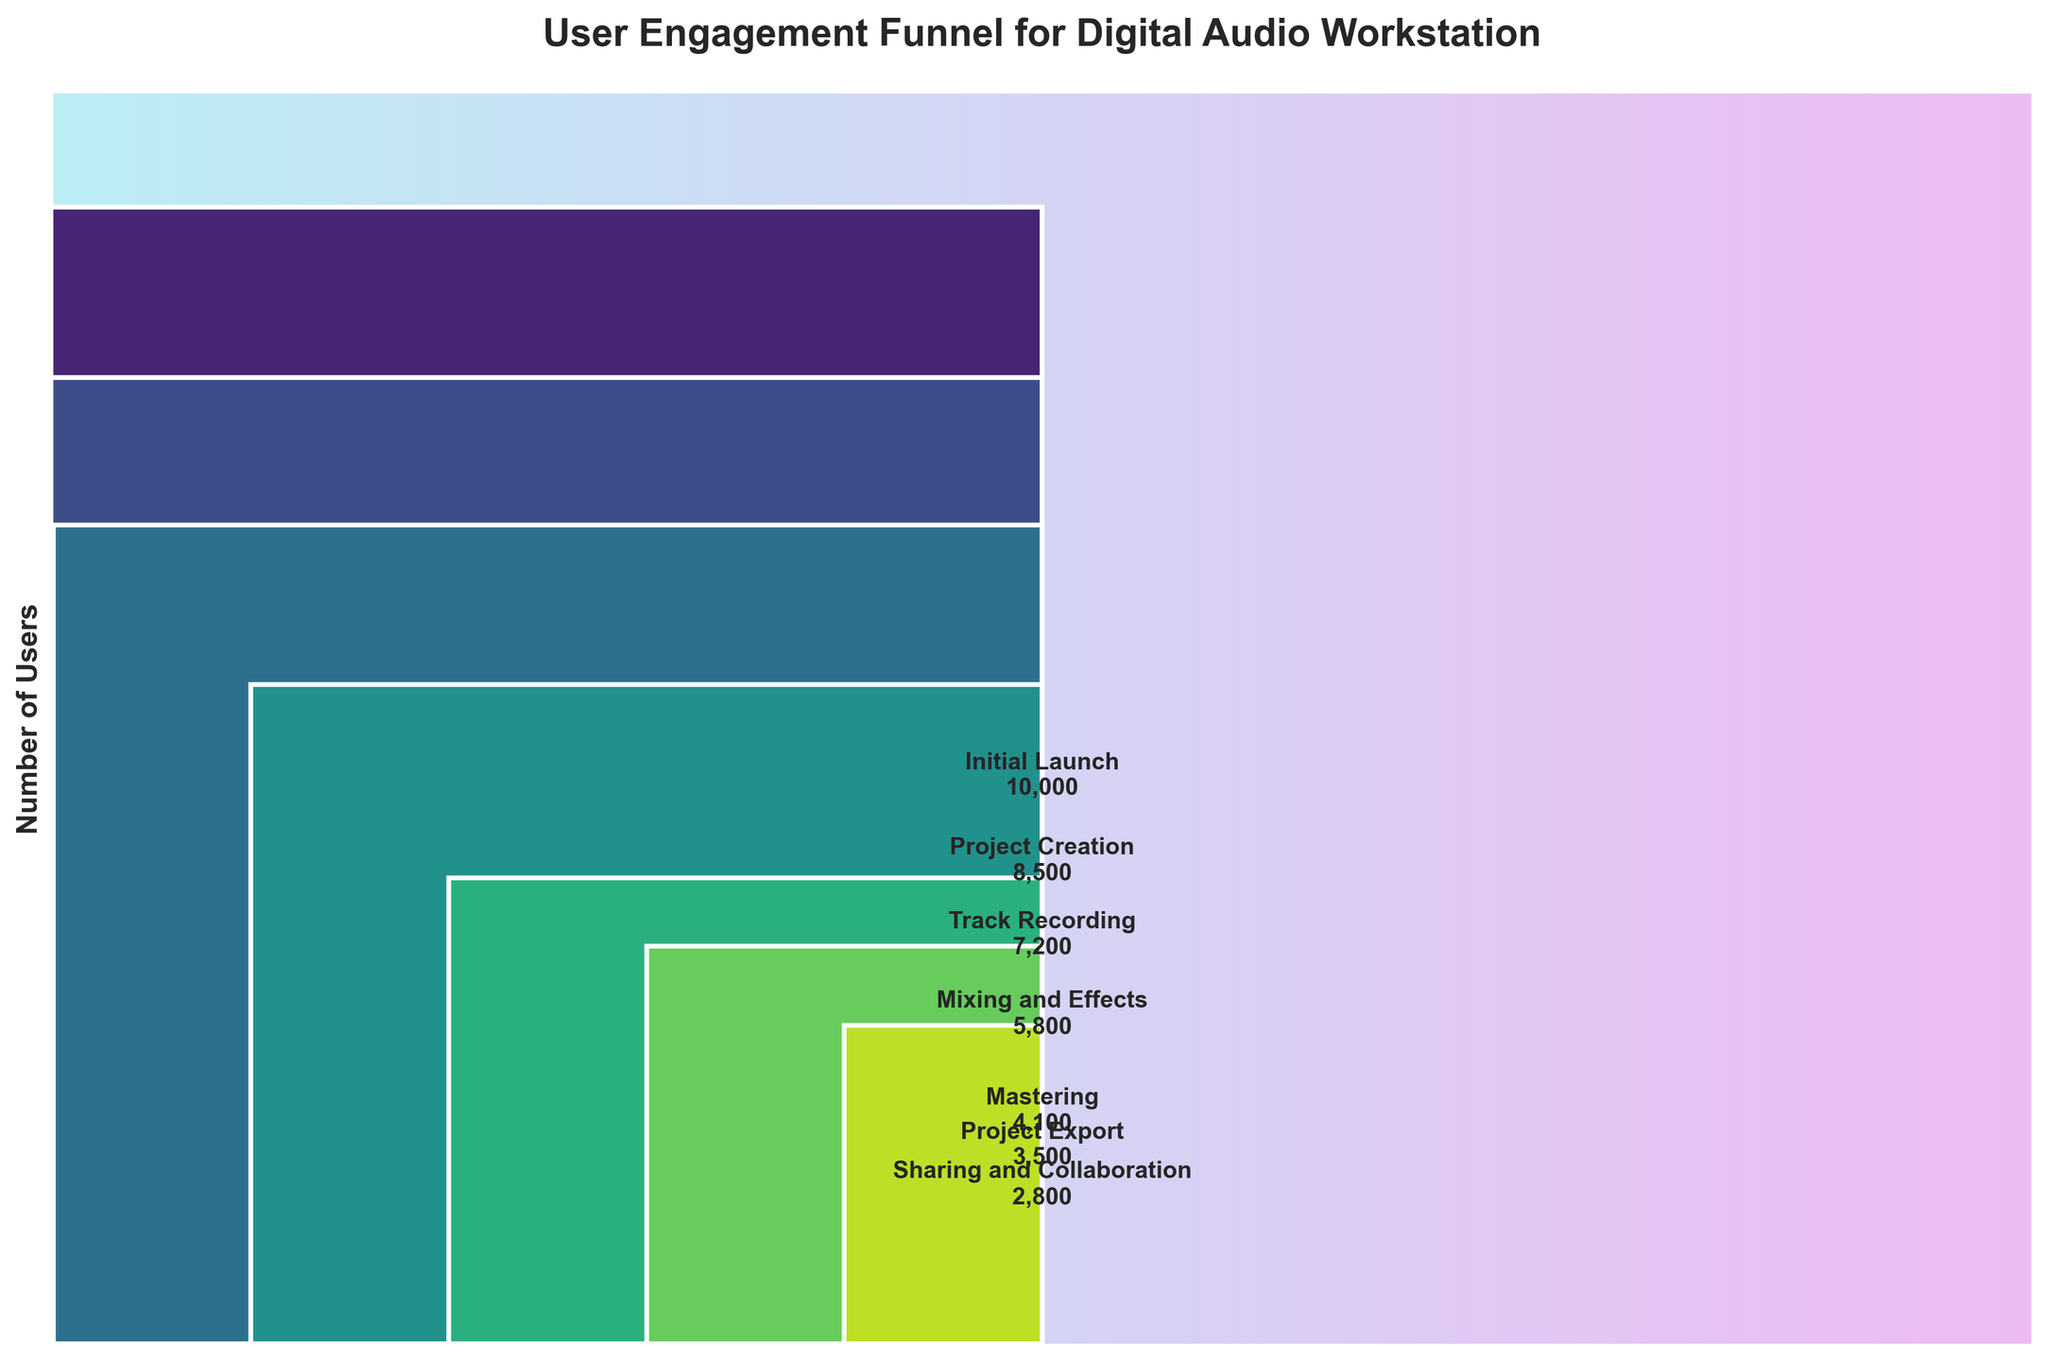How many users entered the 'Mixing and Effects' stage? Look at the section labeled 'Mixing and Effects' in the funnel chart and the corresponding number of users.
Answer: 5800 Which stage has the highest number of users? Identify the tallest bar in the funnel chart which corresponds to the highest number of users. That stage is 'Initial Launch'.
Answer: Initial Launch What is the total number of users that dropped off between the 'Track Recording' and 'Project Completion' stages? First, identify the number of users at the 'Track Recording' stage (7200) and the 'Project Export' stage (3500). Subtract the latter from the former to get the number of users who dropped off. 7200 - 3500 = 3700
Answer: 3700 What is the average number of users across all stages? Sum the number of users at each stage (10000 + 8500 + 7200 + 5800 + 4100 + 3500 + 2800) and divide by the number of stages (7). The total sum is 42500; thus, the average is 42500 / 7 = 6071.43
Answer: 6071.43 By how much did the user count decrease from 'Mastering' to 'Project Export'? Look at the number of users at the 'Mastering' stage (4100) and the 'Project Export' stage (3500). Subtract the latter from the former: 4100 - 3500 = 600
Answer: 600 Which stage saw the largest drop in users compared to its previous stage? Compare the user decline between each successive stage: 
* Initial Launch to Project Creation: 10000 - 8500 = 1500 
* Project Creation to Track Recording: 8500 - 7200 = 1300 
* Track Recording to Mixing and Effects: 7200 - 5800 = 1400 
* Mixing and Effects to Mastering: 5800 - 4100 = 1700 
* Mastering to Project Export: 4100 - 3500 = 600 
* Project Export to Sharing and Collaboration: 3500 - 2800 = 700 
The largest drop is from Mixing and Effects to Mastering with 1700 users.
Answer: Mixing and Effects to Mastering What percentage of users who started the initial launch stayed until the project export stage? Take the number of users at the 'Project Export' stage (3500) and divide it by the number of users at the 'Initial Launch' stage (10000), then multiply by 100 to get the percentage: (3500 / 10000) * 100 = 35%
Answer: 35% What is the ratio of users in the 'Track Recording' stage to those in the 'Sharing and Collaboration' stage? Divide the number of users in 'Track Recording' (7200) by the number of users in 'Sharing and Collaboration' (2800). The ratio is 7200 / 2800 = 2.57
Answer: 2.57 Which two consecutive stages show the smallest drop in user numbers? Compare the user decline between each successive stage: 
* Initial Launch to Project Creation: 1500 
* Project Creation to Track Recording: 1300 
* Track Recording to Mixing and Effects: 1400 
* Mixing and Effects to Mastering: 1700 
* Mastering to Project Export: 600 
* Project Export to Sharing and Collaboration: 700
The smallest drop is from Mastering to Project Export with a drop of 600 users.
Answer: Mastering to Project Export 